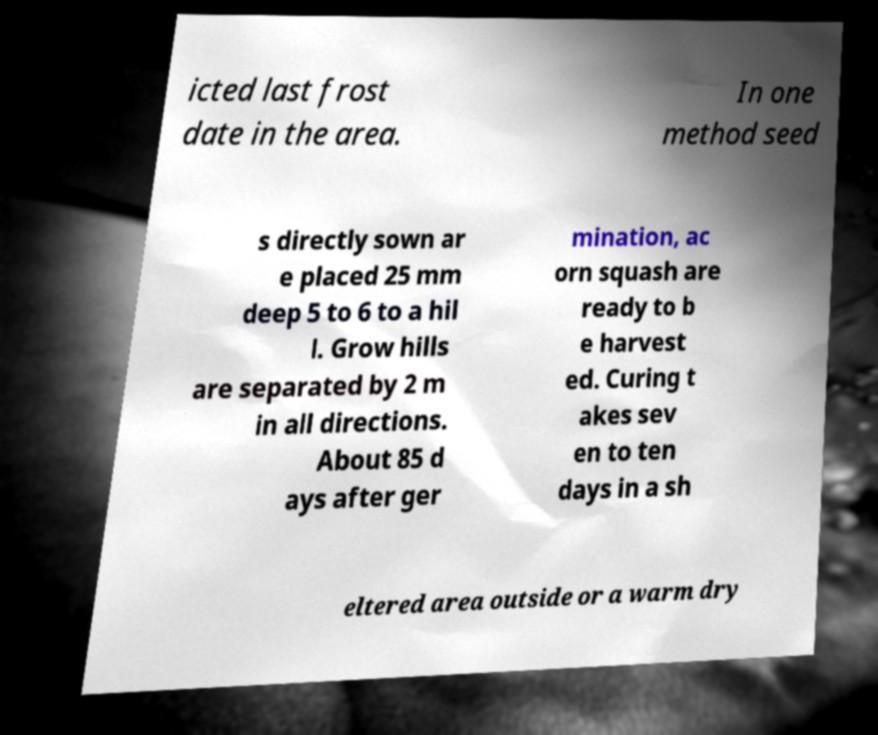I need the written content from this picture converted into text. Can you do that? icted last frost date in the area. In one method seed s directly sown ar e placed 25 mm deep 5 to 6 to a hil l. Grow hills are separated by 2 m in all directions. About 85 d ays after ger mination, ac orn squash are ready to b e harvest ed. Curing t akes sev en to ten days in a sh eltered area outside or a warm dry 